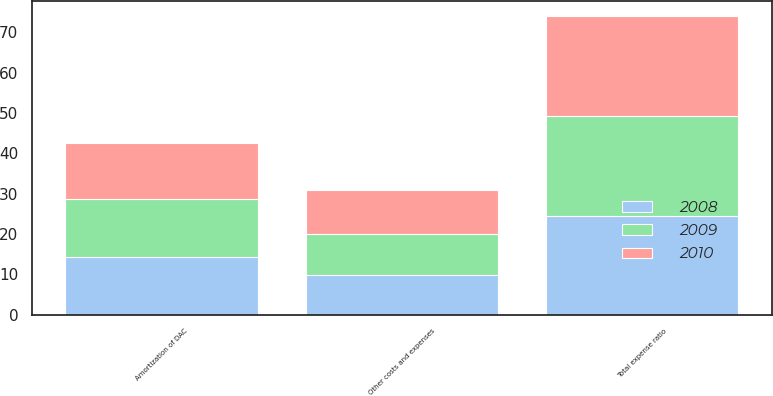Convert chart to OTSL. <chart><loc_0><loc_0><loc_500><loc_500><stacked_bar_chart><ecel><fcel>Amortization of DAC<fcel>Other costs and expenses<fcel>Total expense ratio<nl><fcel>2010<fcel>14<fcel>10.8<fcel>24.9<nl><fcel>2008<fcel>14.2<fcel>9.9<fcel>24.5<nl><fcel>2009<fcel>14.4<fcel>10.2<fcel>24.7<nl></chart> 